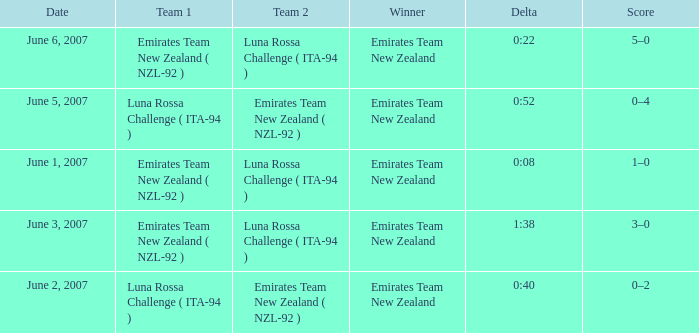Who is the Winner on June 2, 2007? Emirates Team New Zealand. 